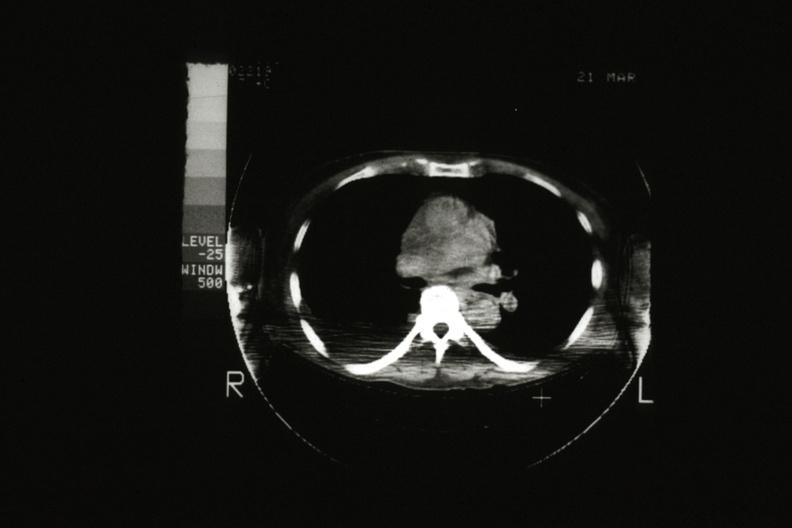what scan showing tumor mass invading superior vena ca?
Answer the question using a single word or phrase. Cat 